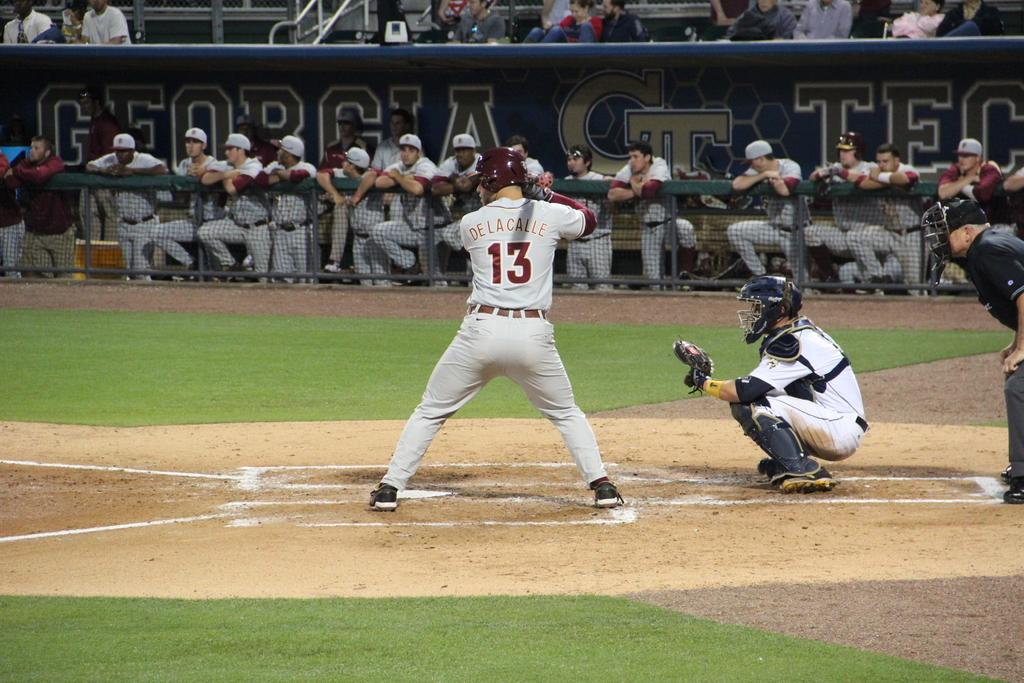<image>
Share a concise interpretation of the image provided. a player that is number 13 readies to hit 